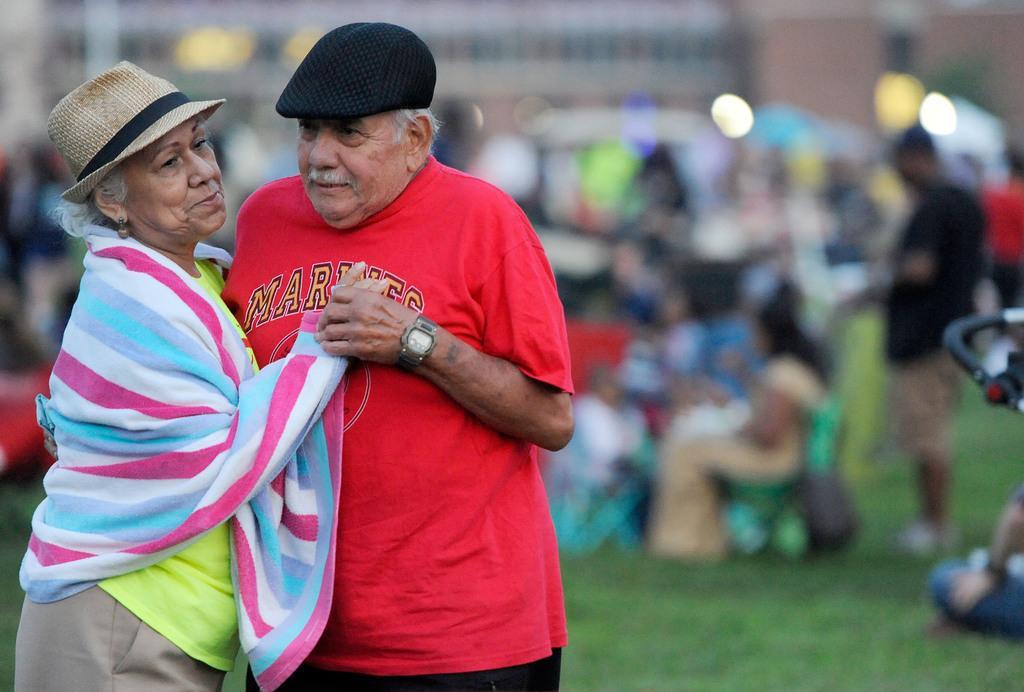Please provide a concise description of this image. This picture is clicked outside. On the left we can see the two persons wearing t-shirts, hats and standing on the ground. In the background we can see the green grass and group of persons and some buildings. The background of the image is blurry. 